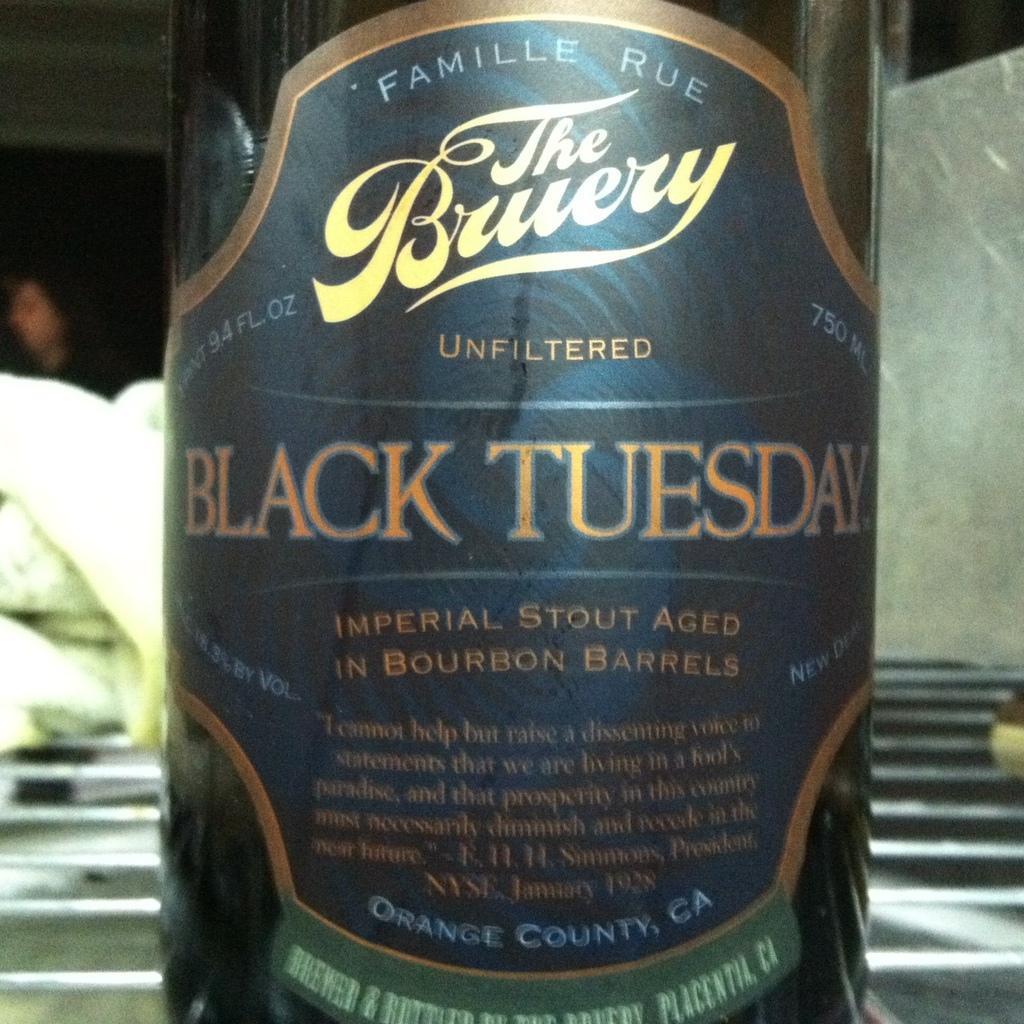What is the title of this drink?
Your response must be concise. Black tuesday. 